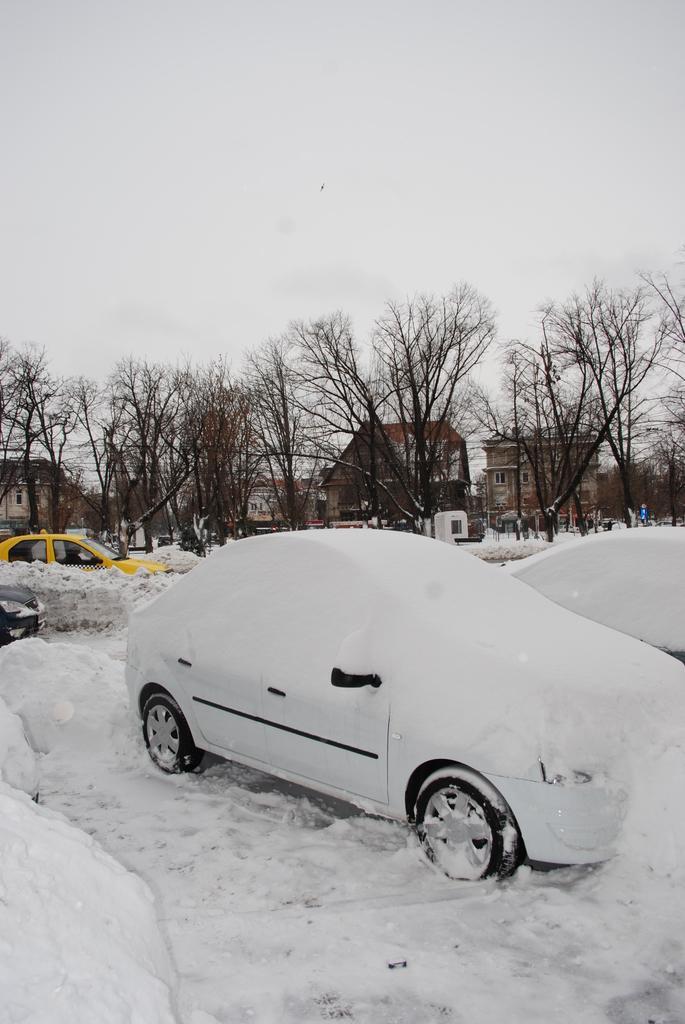Can you describe this image briefly? This image consists of many vehicles. In the front, there is a car in white color which is covered with snow. In the background, there are many trees and buildings. At the top, there is sky. 